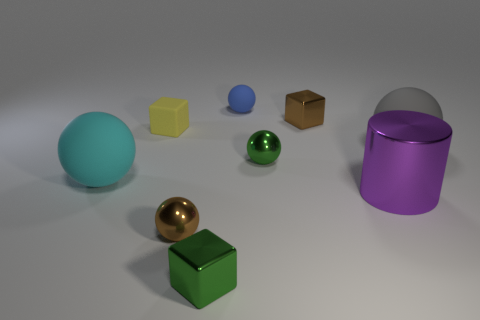What number of tiny blue things are behind the cyan sphere?
Your response must be concise. 1. What is the big purple cylinder made of?
Offer a terse response. Metal. Is the metal cylinder the same color as the tiny rubber ball?
Provide a succinct answer. No. Are there fewer tiny green metallic spheres that are right of the blue object than big cyan balls?
Your answer should be compact. No. The big matte sphere that is on the right side of the brown shiny ball is what color?
Your answer should be compact. Gray. The purple metallic object has what shape?
Offer a very short reply. Cylinder. There is a small brown thing to the right of the brown object in front of the gray matte thing; is there a metallic ball to the right of it?
Keep it short and to the point. No. There is a cube that is in front of the object that is right of the purple thing in front of the large cyan rubber object; what color is it?
Make the answer very short. Green. What material is the brown object that is the same shape as the small blue rubber object?
Ensure brevity in your answer.  Metal. There is a brown shiny thing behind the big gray rubber sphere that is right of the purple metal cylinder; what size is it?
Ensure brevity in your answer.  Small. 